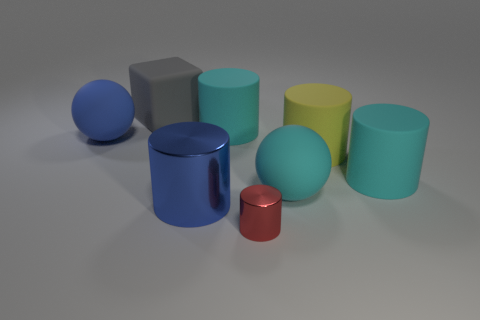What is the material of the big ball that is on the right side of the cyan matte cylinder left of the rubber sphere right of the big blue shiny object?
Your answer should be very brief. Rubber. Is the number of yellow rubber objects less than the number of green metal blocks?
Provide a short and direct response. No. Do the large gray object and the tiny cylinder have the same material?
Offer a terse response. No. There is a large matte thing that is the same color as the big shiny cylinder; what shape is it?
Keep it short and to the point. Sphere. Is the color of the big rubber object that is left of the large block the same as the big shiny cylinder?
Your response must be concise. Yes. There is a ball left of the big gray rubber block; how many big blue matte objects are to the right of it?
Make the answer very short. 0. There is a matte sphere that is the same size as the blue matte thing; what is its color?
Your answer should be compact. Cyan. There is a gray thing that is behind the large blue shiny cylinder; what is its material?
Your answer should be very brief. Rubber. What is the material of the big cylinder that is on the right side of the blue metallic cylinder and to the left of the red thing?
Give a very brief answer. Rubber. There is a sphere to the right of the block; is it the same size as the block?
Offer a terse response. Yes. 